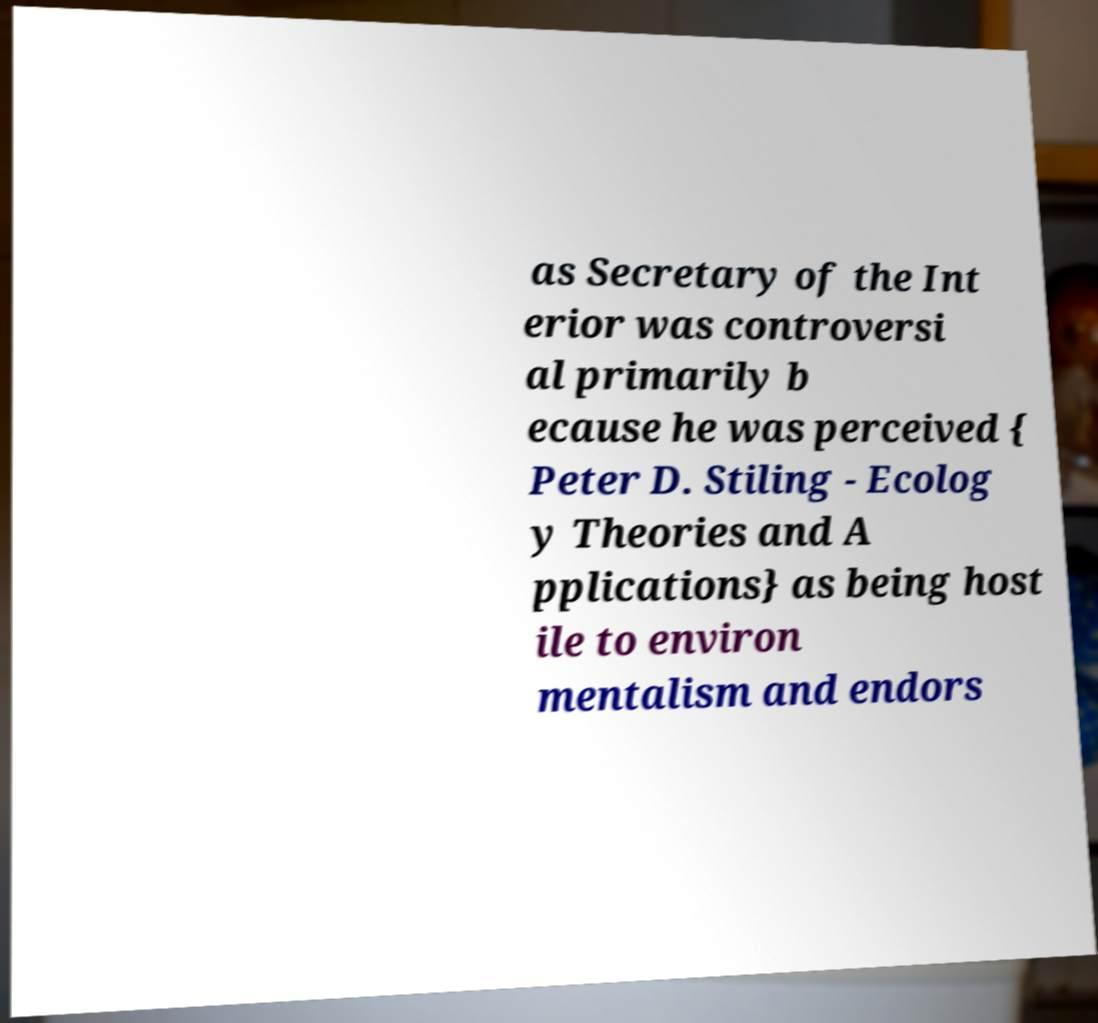Can you accurately transcribe the text from the provided image for me? as Secretary of the Int erior was controversi al primarily b ecause he was perceived { Peter D. Stiling - Ecolog y Theories and A pplications} as being host ile to environ mentalism and endors 